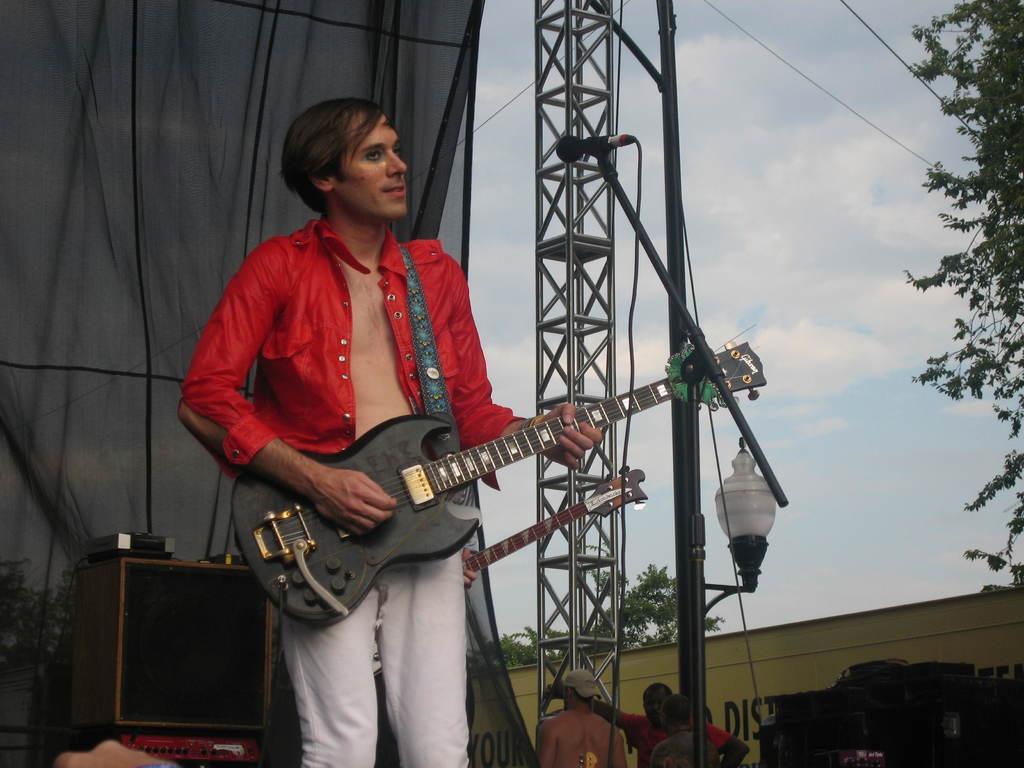Could you give a brief overview of what you see in this image? In this picture in the front there is a person standing and playing a musical instrument. In the background there are musical instruments, poles, persons and there is a board with some text written on it and there are trees, there is a curtain which is black in colour and the sky is cloudy. 